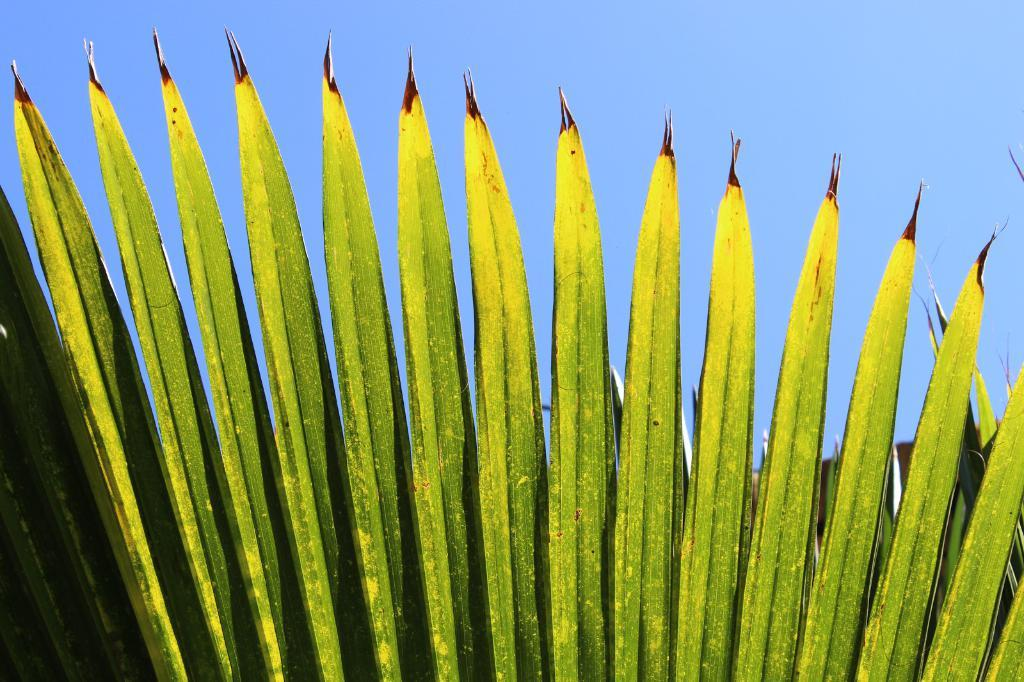What type of vegetation can be seen in the image? There are leaves in the image. What part of the natural environment is visible in the image? The sky is visible in the background of the image. Where is the camera located in the image? There is no camera present in the image. What type of fruit can be seen in the image? There are no fruits visible in the image, only leaves. 